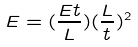<formula> <loc_0><loc_0><loc_500><loc_500>E = ( \frac { E t } { L } ) ( \frac { L } { t } ) ^ { 2 }</formula> 